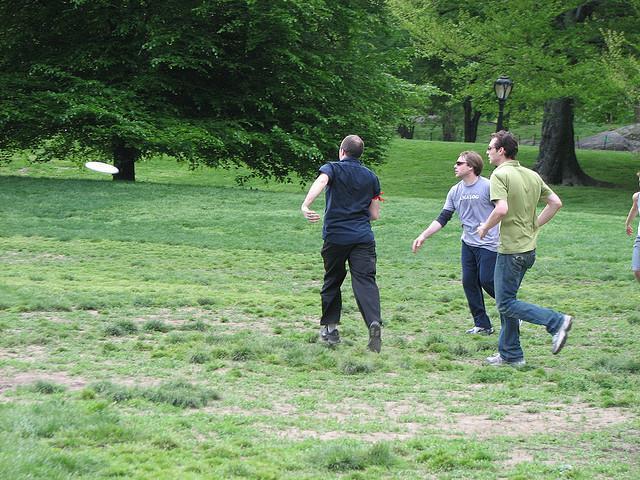How many street lights are in the picture?
Give a very brief answer. 1. How many women are playing the game?
Give a very brief answer. 0. How many people are visible?
Give a very brief answer. 3. How many motorcycles are parked?
Give a very brief answer. 0. 